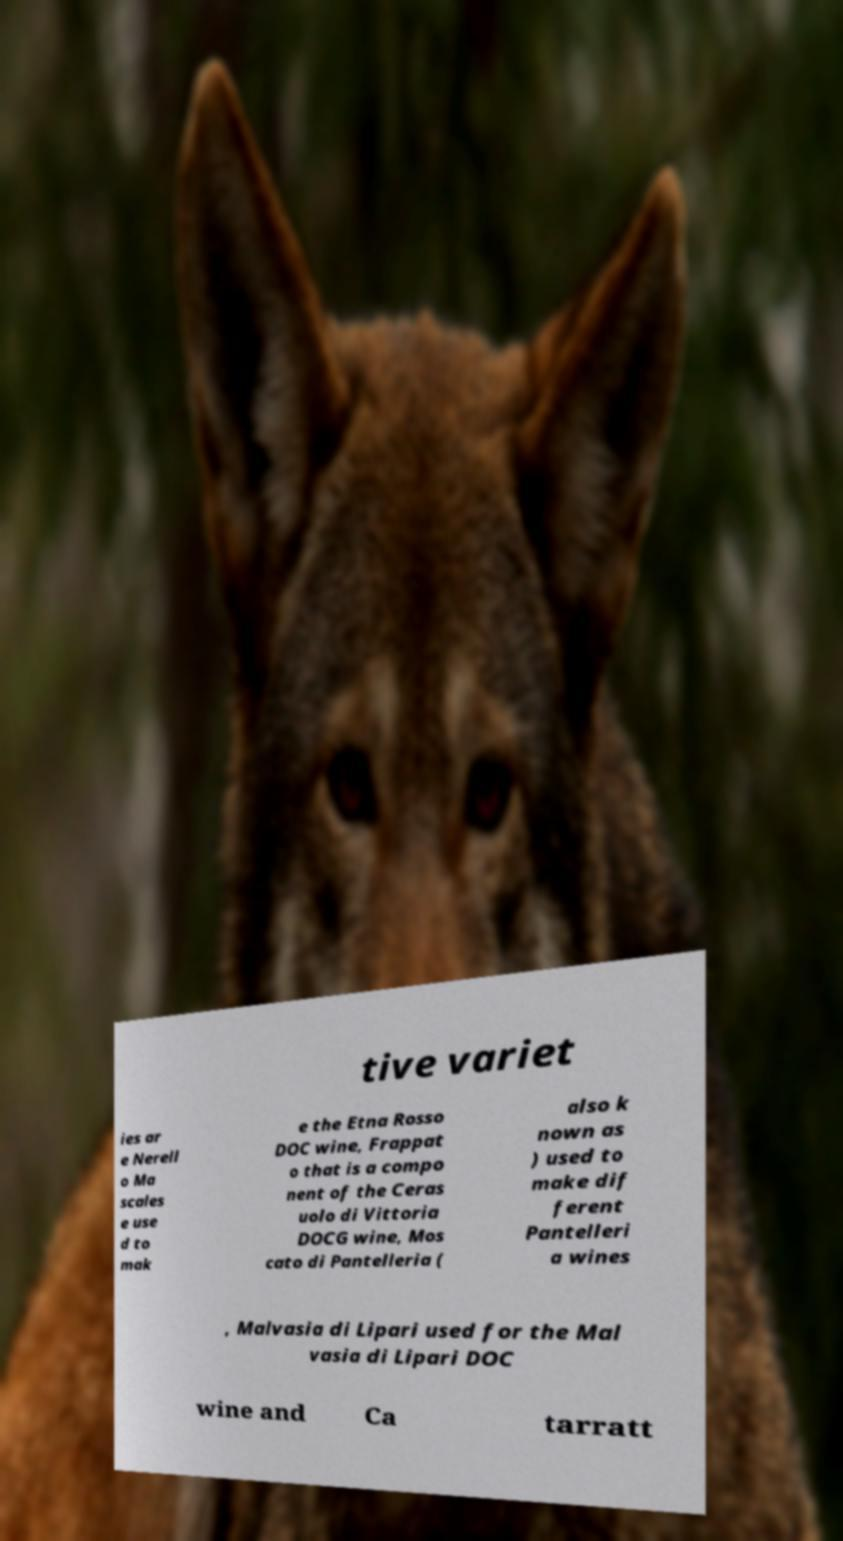What messages or text are displayed in this image? I need them in a readable, typed format. tive variet ies ar e Nerell o Ma scales e use d to mak e the Etna Rosso DOC wine, Frappat o that is a compo nent of the Ceras uolo di Vittoria DOCG wine, Mos cato di Pantelleria ( also k nown as ) used to make dif ferent Pantelleri a wines , Malvasia di Lipari used for the Mal vasia di Lipari DOC wine and Ca tarratt 